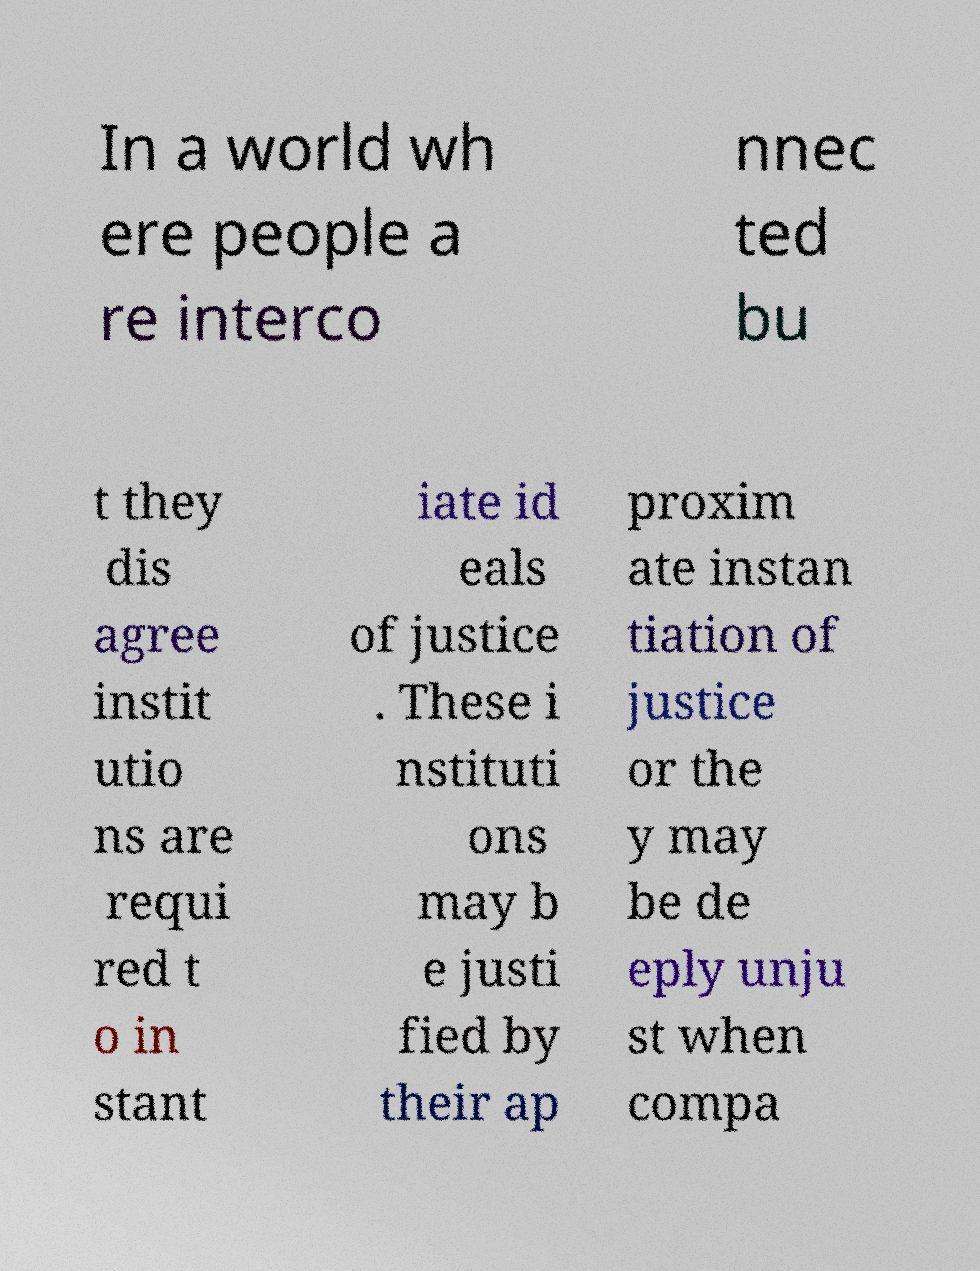For documentation purposes, I need the text within this image transcribed. Could you provide that? In a world wh ere people a re interco nnec ted bu t they dis agree instit utio ns are requi red t o in stant iate id eals of justice . These i nstituti ons may b e justi fied by their ap proxim ate instan tiation of justice or the y may be de eply unju st when compa 